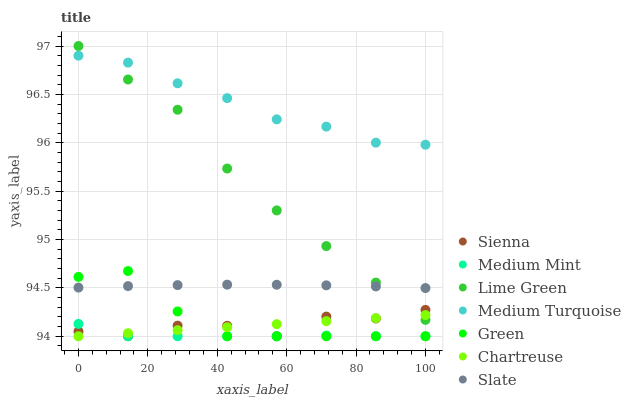Does Medium Mint have the minimum area under the curve?
Answer yes or no. Yes. Does Medium Turquoise have the maximum area under the curve?
Answer yes or no. Yes. Does Slate have the minimum area under the curve?
Answer yes or no. No. Does Slate have the maximum area under the curve?
Answer yes or no. No. Is Chartreuse the smoothest?
Answer yes or no. Yes. Is Sienna the roughest?
Answer yes or no. Yes. Is Slate the smoothest?
Answer yes or no. No. Is Slate the roughest?
Answer yes or no. No. Does Medium Mint have the lowest value?
Answer yes or no. Yes. Does Slate have the lowest value?
Answer yes or no. No. Does Lime Green have the highest value?
Answer yes or no. Yes. Does Slate have the highest value?
Answer yes or no. No. Is Green less than Medium Turquoise?
Answer yes or no. Yes. Is Lime Green greater than Medium Mint?
Answer yes or no. Yes. Does Green intersect Medium Mint?
Answer yes or no. Yes. Is Green less than Medium Mint?
Answer yes or no. No. Is Green greater than Medium Mint?
Answer yes or no. No. Does Green intersect Medium Turquoise?
Answer yes or no. No. 